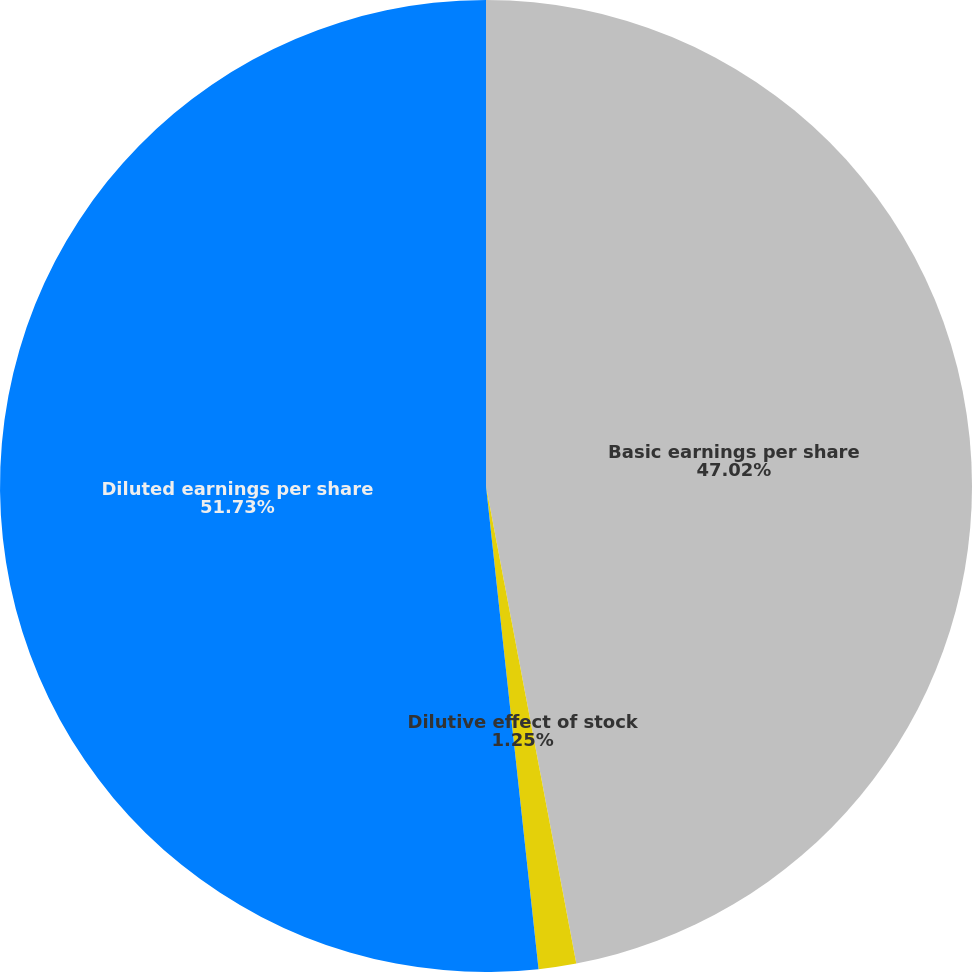Convert chart to OTSL. <chart><loc_0><loc_0><loc_500><loc_500><pie_chart><fcel>Basic earnings per share<fcel>Dilutive effect of stock<fcel>Diluted earnings per share<nl><fcel>47.02%<fcel>1.25%<fcel>51.72%<nl></chart> 